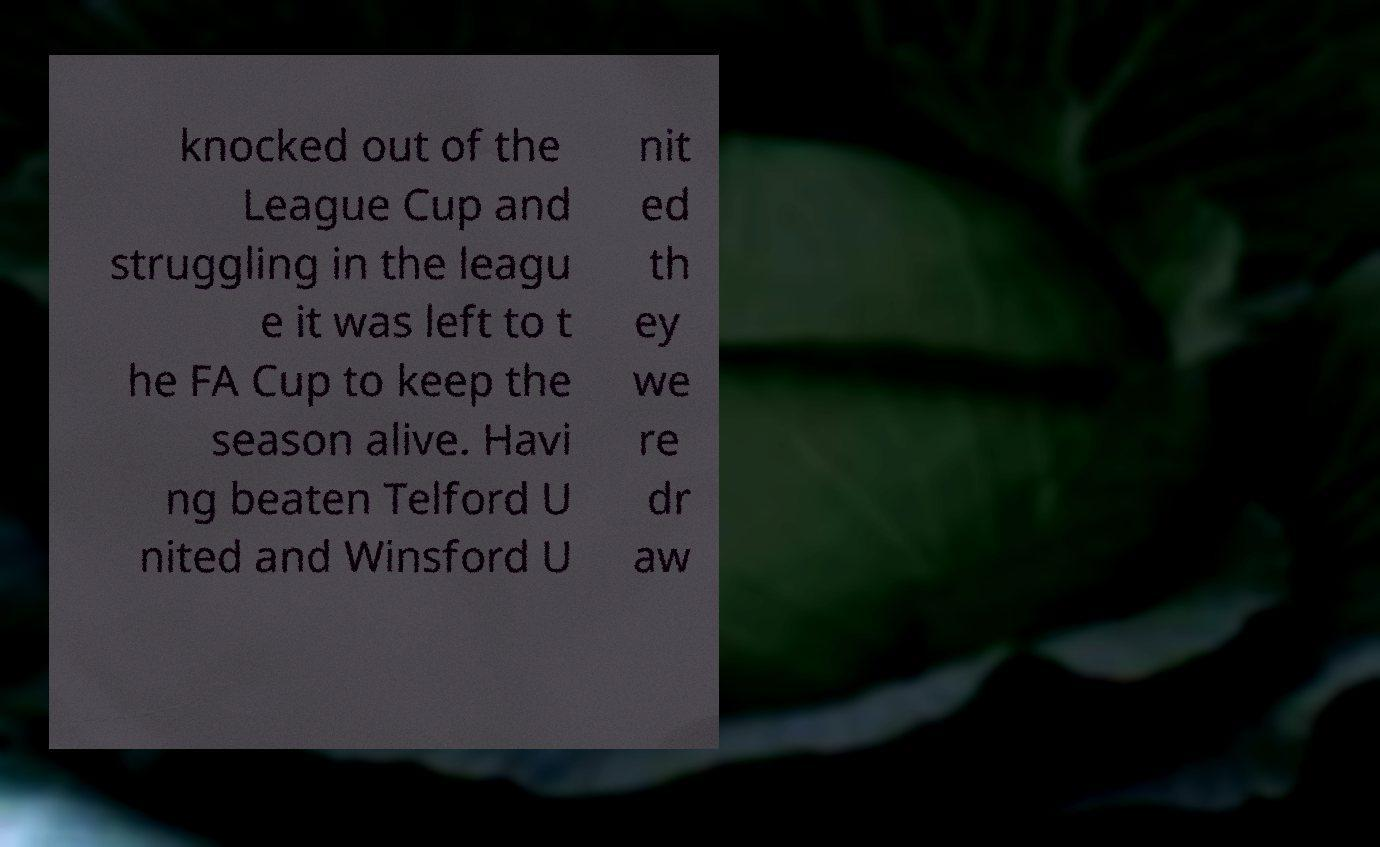Could you assist in decoding the text presented in this image and type it out clearly? knocked out of the League Cup and struggling in the leagu e it was left to t he FA Cup to keep the season alive. Havi ng beaten Telford U nited and Winsford U nit ed th ey we re dr aw 